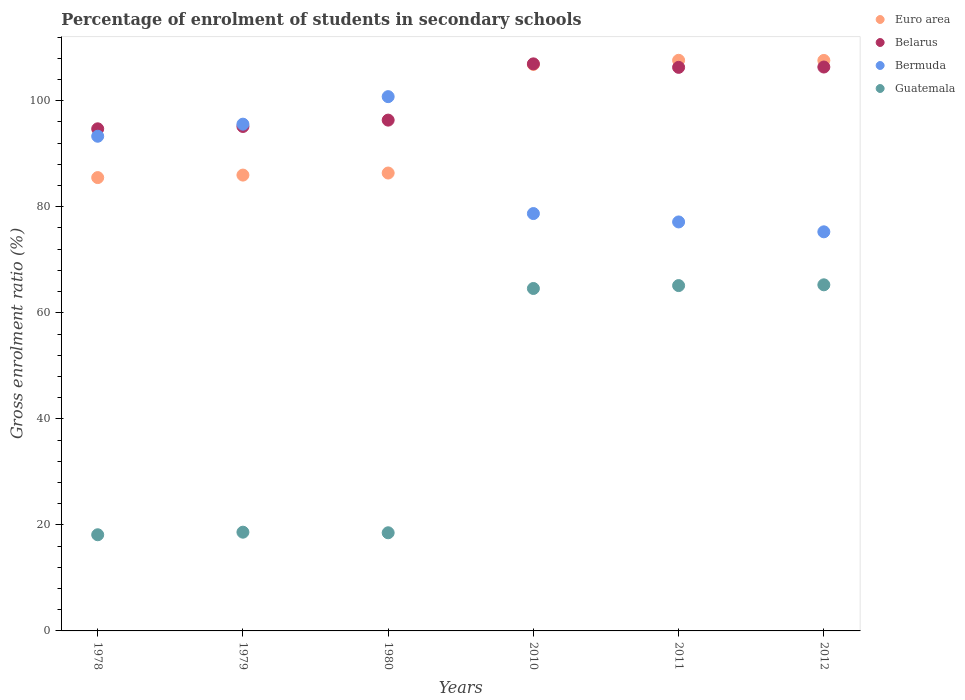What is the percentage of students enrolled in secondary schools in Euro area in 2011?
Offer a terse response. 107.63. Across all years, what is the maximum percentage of students enrolled in secondary schools in Bermuda?
Offer a very short reply. 100.78. Across all years, what is the minimum percentage of students enrolled in secondary schools in Guatemala?
Give a very brief answer. 18.14. In which year was the percentage of students enrolled in secondary schools in Euro area maximum?
Give a very brief answer. 2011. In which year was the percentage of students enrolled in secondary schools in Belarus minimum?
Make the answer very short. 1978. What is the total percentage of students enrolled in secondary schools in Euro area in the graph?
Your answer should be very brief. 579.94. What is the difference between the percentage of students enrolled in secondary schools in Belarus in 1978 and that in 2012?
Keep it short and to the point. -11.65. What is the difference between the percentage of students enrolled in secondary schools in Belarus in 2011 and the percentage of students enrolled in secondary schools in Bermuda in 1979?
Your response must be concise. 10.72. What is the average percentage of students enrolled in secondary schools in Euro area per year?
Ensure brevity in your answer.  96.66. In the year 2011, what is the difference between the percentage of students enrolled in secondary schools in Belarus and percentage of students enrolled in secondary schools in Guatemala?
Provide a short and direct response. 41.17. What is the ratio of the percentage of students enrolled in secondary schools in Belarus in 2010 to that in 2011?
Your response must be concise. 1.01. Is the percentage of students enrolled in secondary schools in Euro area in 2010 less than that in 2012?
Provide a succinct answer. Yes. Is the difference between the percentage of students enrolled in secondary schools in Belarus in 2010 and 2012 greater than the difference between the percentage of students enrolled in secondary schools in Guatemala in 2010 and 2012?
Offer a terse response. Yes. What is the difference between the highest and the second highest percentage of students enrolled in secondary schools in Guatemala?
Your answer should be very brief. 0.15. What is the difference between the highest and the lowest percentage of students enrolled in secondary schools in Bermuda?
Ensure brevity in your answer.  25.5. In how many years, is the percentage of students enrolled in secondary schools in Euro area greater than the average percentage of students enrolled in secondary schools in Euro area taken over all years?
Offer a terse response. 3. Is the sum of the percentage of students enrolled in secondary schools in Guatemala in 1979 and 2012 greater than the maximum percentage of students enrolled in secondary schools in Euro area across all years?
Give a very brief answer. No. Is it the case that in every year, the sum of the percentage of students enrolled in secondary schools in Euro area and percentage of students enrolled in secondary schools in Belarus  is greater than the sum of percentage of students enrolled in secondary schools in Guatemala and percentage of students enrolled in secondary schools in Bermuda?
Your answer should be very brief. Yes. Is it the case that in every year, the sum of the percentage of students enrolled in secondary schools in Euro area and percentage of students enrolled in secondary schools in Belarus  is greater than the percentage of students enrolled in secondary schools in Guatemala?
Your answer should be very brief. Yes. Is the percentage of students enrolled in secondary schools in Belarus strictly greater than the percentage of students enrolled in secondary schools in Guatemala over the years?
Make the answer very short. Yes. How many dotlines are there?
Ensure brevity in your answer.  4. How many years are there in the graph?
Your answer should be very brief. 6. What is the difference between two consecutive major ticks on the Y-axis?
Keep it short and to the point. 20. Are the values on the major ticks of Y-axis written in scientific E-notation?
Your answer should be compact. No. Does the graph contain any zero values?
Offer a very short reply. No. What is the title of the graph?
Your response must be concise. Percentage of enrolment of students in secondary schools. What is the label or title of the X-axis?
Your answer should be very brief. Years. What is the Gross enrolment ratio (%) of Euro area in 1978?
Offer a terse response. 85.51. What is the Gross enrolment ratio (%) of Belarus in 1978?
Your answer should be very brief. 94.71. What is the Gross enrolment ratio (%) of Bermuda in 1978?
Provide a succinct answer. 93.31. What is the Gross enrolment ratio (%) in Guatemala in 1978?
Provide a short and direct response. 18.14. What is the Gross enrolment ratio (%) of Euro area in 1979?
Your response must be concise. 85.98. What is the Gross enrolment ratio (%) of Belarus in 1979?
Make the answer very short. 95.15. What is the Gross enrolment ratio (%) of Bermuda in 1979?
Offer a terse response. 95.59. What is the Gross enrolment ratio (%) in Guatemala in 1979?
Make the answer very short. 18.62. What is the Gross enrolment ratio (%) of Euro area in 1980?
Give a very brief answer. 86.37. What is the Gross enrolment ratio (%) in Belarus in 1980?
Provide a succinct answer. 96.35. What is the Gross enrolment ratio (%) of Bermuda in 1980?
Offer a very short reply. 100.78. What is the Gross enrolment ratio (%) in Guatemala in 1980?
Make the answer very short. 18.51. What is the Gross enrolment ratio (%) of Euro area in 2010?
Offer a terse response. 106.85. What is the Gross enrolment ratio (%) of Belarus in 2010?
Give a very brief answer. 106.96. What is the Gross enrolment ratio (%) of Bermuda in 2010?
Ensure brevity in your answer.  78.72. What is the Gross enrolment ratio (%) of Guatemala in 2010?
Offer a very short reply. 64.59. What is the Gross enrolment ratio (%) in Euro area in 2011?
Give a very brief answer. 107.63. What is the Gross enrolment ratio (%) in Belarus in 2011?
Keep it short and to the point. 106.3. What is the Gross enrolment ratio (%) of Bermuda in 2011?
Provide a short and direct response. 77.14. What is the Gross enrolment ratio (%) in Guatemala in 2011?
Your answer should be very brief. 65.14. What is the Gross enrolment ratio (%) of Euro area in 2012?
Offer a terse response. 107.6. What is the Gross enrolment ratio (%) of Belarus in 2012?
Make the answer very short. 106.36. What is the Gross enrolment ratio (%) in Bermuda in 2012?
Offer a terse response. 75.28. What is the Gross enrolment ratio (%) in Guatemala in 2012?
Give a very brief answer. 65.28. Across all years, what is the maximum Gross enrolment ratio (%) of Euro area?
Your answer should be compact. 107.63. Across all years, what is the maximum Gross enrolment ratio (%) of Belarus?
Ensure brevity in your answer.  106.96. Across all years, what is the maximum Gross enrolment ratio (%) of Bermuda?
Keep it short and to the point. 100.78. Across all years, what is the maximum Gross enrolment ratio (%) in Guatemala?
Your response must be concise. 65.28. Across all years, what is the minimum Gross enrolment ratio (%) in Euro area?
Keep it short and to the point. 85.51. Across all years, what is the minimum Gross enrolment ratio (%) of Belarus?
Give a very brief answer. 94.71. Across all years, what is the minimum Gross enrolment ratio (%) of Bermuda?
Your answer should be compact. 75.28. Across all years, what is the minimum Gross enrolment ratio (%) in Guatemala?
Keep it short and to the point. 18.14. What is the total Gross enrolment ratio (%) in Euro area in the graph?
Offer a very short reply. 579.94. What is the total Gross enrolment ratio (%) of Belarus in the graph?
Provide a succinct answer. 605.83. What is the total Gross enrolment ratio (%) of Bermuda in the graph?
Your answer should be very brief. 520.82. What is the total Gross enrolment ratio (%) in Guatemala in the graph?
Your response must be concise. 250.29. What is the difference between the Gross enrolment ratio (%) of Euro area in 1978 and that in 1979?
Ensure brevity in your answer.  -0.47. What is the difference between the Gross enrolment ratio (%) of Belarus in 1978 and that in 1979?
Offer a very short reply. -0.44. What is the difference between the Gross enrolment ratio (%) of Bermuda in 1978 and that in 1979?
Your answer should be compact. -2.28. What is the difference between the Gross enrolment ratio (%) in Guatemala in 1978 and that in 1979?
Your response must be concise. -0.48. What is the difference between the Gross enrolment ratio (%) in Euro area in 1978 and that in 1980?
Offer a terse response. -0.86. What is the difference between the Gross enrolment ratio (%) in Belarus in 1978 and that in 1980?
Your answer should be very brief. -1.64. What is the difference between the Gross enrolment ratio (%) of Bermuda in 1978 and that in 1980?
Your answer should be compact. -7.47. What is the difference between the Gross enrolment ratio (%) in Guatemala in 1978 and that in 1980?
Provide a short and direct response. -0.37. What is the difference between the Gross enrolment ratio (%) of Euro area in 1978 and that in 2010?
Your response must be concise. -21.34. What is the difference between the Gross enrolment ratio (%) of Belarus in 1978 and that in 2010?
Provide a succinct answer. -12.25. What is the difference between the Gross enrolment ratio (%) in Bermuda in 1978 and that in 2010?
Offer a very short reply. 14.58. What is the difference between the Gross enrolment ratio (%) in Guatemala in 1978 and that in 2010?
Provide a succinct answer. -46.45. What is the difference between the Gross enrolment ratio (%) in Euro area in 1978 and that in 2011?
Your answer should be very brief. -22.12. What is the difference between the Gross enrolment ratio (%) of Belarus in 1978 and that in 2011?
Provide a short and direct response. -11.59. What is the difference between the Gross enrolment ratio (%) of Bermuda in 1978 and that in 2011?
Your answer should be very brief. 16.16. What is the difference between the Gross enrolment ratio (%) of Guatemala in 1978 and that in 2011?
Provide a short and direct response. -47. What is the difference between the Gross enrolment ratio (%) of Euro area in 1978 and that in 2012?
Provide a short and direct response. -22.1. What is the difference between the Gross enrolment ratio (%) in Belarus in 1978 and that in 2012?
Provide a succinct answer. -11.65. What is the difference between the Gross enrolment ratio (%) in Bermuda in 1978 and that in 2012?
Provide a short and direct response. 18.03. What is the difference between the Gross enrolment ratio (%) of Guatemala in 1978 and that in 2012?
Provide a succinct answer. -47.14. What is the difference between the Gross enrolment ratio (%) of Euro area in 1979 and that in 1980?
Ensure brevity in your answer.  -0.39. What is the difference between the Gross enrolment ratio (%) of Belarus in 1979 and that in 1980?
Give a very brief answer. -1.2. What is the difference between the Gross enrolment ratio (%) in Bermuda in 1979 and that in 1980?
Give a very brief answer. -5.19. What is the difference between the Gross enrolment ratio (%) of Guatemala in 1979 and that in 1980?
Give a very brief answer. 0.11. What is the difference between the Gross enrolment ratio (%) of Euro area in 1979 and that in 2010?
Your answer should be very brief. -20.87. What is the difference between the Gross enrolment ratio (%) in Belarus in 1979 and that in 2010?
Provide a succinct answer. -11.81. What is the difference between the Gross enrolment ratio (%) of Bermuda in 1979 and that in 2010?
Your response must be concise. 16.86. What is the difference between the Gross enrolment ratio (%) of Guatemala in 1979 and that in 2010?
Your answer should be very brief. -45.97. What is the difference between the Gross enrolment ratio (%) in Euro area in 1979 and that in 2011?
Your answer should be very brief. -21.65. What is the difference between the Gross enrolment ratio (%) of Belarus in 1979 and that in 2011?
Make the answer very short. -11.15. What is the difference between the Gross enrolment ratio (%) of Bermuda in 1979 and that in 2011?
Offer a very short reply. 18.44. What is the difference between the Gross enrolment ratio (%) of Guatemala in 1979 and that in 2011?
Your answer should be very brief. -46.51. What is the difference between the Gross enrolment ratio (%) of Euro area in 1979 and that in 2012?
Your answer should be compact. -21.62. What is the difference between the Gross enrolment ratio (%) of Belarus in 1979 and that in 2012?
Provide a short and direct response. -11.21. What is the difference between the Gross enrolment ratio (%) in Bermuda in 1979 and that in 2012?
Your answer should be compact. 20.3. What is the difference between the Gross enrolment ratio (%) in Guatemala in 1979 and that in 2012?
Ensure brevity in your answer.  -46.66. What is the difference between the Gross enrolment ratio (%) in Euro area in 1980 and that in 2010?
Provide a short and direct response. -20.48. What is the difference between the Gross enrolment ratio (%) in Belarus in 1980 and that in 2010?
Ensure brevity in your answer.  -10.61. What is the difference between the Gross enrolment ratio (%) in Bermuda in 1980 and that in 2010?
Ensure brevity in your answer.  22.05. What is the difference between the Gross enrolment ratio (%) of Guatemala in 1980 and that in 2010?
Your answer should be very brief. -46.08. What is the difference between the Gross enrolment ratio (%) of Euro area in 1980 and that in 2011?
Your answer should be compact. -21.26. What is the difference between the Gross enrolment ratio (%) in Belarus in 1980 and that in 2011?
Your response must be concise. -9.95. What is the difference between the Gross enrolment ratio (%) of Bermuda in 1980 and that in 2011?
Offer a very short reply. 23.63. What is the difference between the Gross enrolment ratio (%) of Guatemala in 1980 and that in 2011?
Your answer should be compact. -46.63. What is the difference between the Gross enrolment ratio (%) of Euro area in 1980 and that in 2012?
Your response must be concise. -21.23. What is the difference between the Gross enrolment ratio (%) of Belarus in 1980 and that in 2012?
Make the answer very short. -10.01. What is the difference between the Gross enrolment ratio (%) of Bermuda in 1980 and that in 2012?
Ensure brevity in your answer.  25.5. What is the difference between the Gross enrolment ratio (%) of Guatemala in 1980 and that in 2012?
Offer a very short reply. -46.77. What is the difference between the Gross enrolment ratio (%) in Euro area in 2010 and that in 2011?
Provide a succinct answer. -0.78. What is the difference between the Gross enrolment ratio (%) of Belarus in 2010 and that in 2011?
Keep it short and to the point. 0.66. What is the difference between the Gross enrolment ratio (%) of Bermuda in 2010 and that in 2011?
Give a very brief answer. 1.58. What is the difference between the Gross enrolment ratio (%) of Guatemala in 2010 and that in 2011?
Keep it short and to the point. -0.55. What is the difference between the Gross enrolment ratio (%) in Euro area in 2010 and that in 2012?
Provide a succinct answer. -0.76. What is the difference between the Gross enrolment ratio (%) of Belarus in 2010 and that in 2012?
Your response must be concise. 0.6. What is the difference between the Gross enrolment ratio (%) in Bermuda in 2010 and that in 2012?
Your answer should be very brief. 3.44. What is the difference between the Gross enrolment ratio (%) of Guatemala in 2010 and that in 2012?
Keep it short and to the point. -0.69. What is the difference between the Gross enrolment ratio (%) in Euro area in 2011 and that in 2012?
Offer a very short reply. 0.03. What is the difference between the Gross enrolment ratio (%) of Belarus in 2011 and that in 2012?
Offer a terse response. -0.06. What is the difference between the Gross enrolment ratio (%) in Bermuda in 2011 and that in 2012?
Make the answer very short. 1.86. What is the difference between the Gross enrolment ratio (%) in Guatemala in 2011 and that in 2012?
Your answer should be very brief. -0.15. What is the difference between the Gross enrolment ratio (%) in Euro area in 1978 and the Gross enrolment ratio (%) in Belarus in 1979?
Give a very brief answer. -9.64. What is the difference between the Gross enrolment ratio (%) in Euro area in 1978 and the Gross enrolment ratio (%) in Bermuda in 1979?
Offer a very short reply. -10.08. What is the difference between the Gross enrolment ratio (%) in Euro area in 1978 and the Gross enrolment ratio (%) in Guatemala in 1979?
Ensure brevity in your answer.  66.88. What is the difference between the Gross enrolment ratio (%) of Belarus in 1978 and the Gross enrolment ratio (%) of Bermuda in 1979?
Provide a succinct answer. -0.88. What is the difference between the Gross enrolment ratio (%) of Belarus in 1978 and the Gross enrolment ratio (%) of Guatemala in 1979?
Offer a very short reply. 76.09. What is the difference between the Gross enrolment ratio (%) in Bermuda in 1978 and the Gross enrolment ratio (%) in Guatemala in 1979?
Make the answer very short. 74.68. What is the difference between the Gross enrolment ratio (%) of Euro area in 1978 and the Gross enrolment ratio (%) of Belarus in 1980?
Provide a short and direct response. -10.84. What is the difference between the Gross enrolment ratio (%) of Euro area in 1978 and the Gross enrolment ratio (%) of Bermuda in 1980?
Make the answer very short. -15.27. What is the difference between the Gross enrolment ratio (%) in Euro area in 1978 and the Gross enrolment ratio (%) in Guatemala in 1980?
Provide a succinct answer. 67. What is the difference between the Gross enrolment ratio (%) of Belarus in 1978 and the Gross enrolment ratio (%) of Bermuda in 1980?
Provide a succinct answer. -6.07. What is the difference between the Gross enrolment ratio (%) in Belarus in 1978 and the Gross enrolment ratio (%) in Guatemala in 1980?
Your answer should be compact. 76.2. What is the difference between the Gross enrolment ratio (%) of Bermuda in 1978 and the Gross enrolment ratio (%) of Guatemala in 1980?
Offer a very short reply. 74.79. What is the difference between the Gross enrolment ratio (%) in Euro area in 1978 and the Gross enrolment ratio (%) in Belarus in 2010?
Provide a short and direct response. -21.45. What is the difference between the Gross enrolment ratio (%) in Euro area in 1978 and the Gross enrolment ratio (%) in Bermuda in 2010?
Provide a succinct answer. 6.78. What is the difference between the Gross enrolment ratio (%) in Euro area in 1978 and the Gross enrolment ratio (%) in Guatemala in 2010?
Offer a very short reply. 20.92. What is the difference between the Gross enrolment ratio (%) in Belarus in 1978 and the Gross enrolment ratio (%) in Bermuda in 2010?
Give a very brief answer. 15.98. What is the difference between the Gross enrolment ratio (%) in Belarus in 1978 and the Gross enrolment ratio (%) in Guatemala in 2010?
Offer a terse response. 30.12. What is the difference between the Gross enrolment ratio (%) of Bermuda in 1978 and the Gross enrolment ratio (%) of Guatemala in 2010?
Provide a succinct answer. 28.71. What is the difference between the Gross enrolment ratio (%) in Euro area in 1978 and the Gross enrolment ratio (%) in Belarus in 2011?
Ensure brevity in your answer.  -20.79. What is the difference between the Gross enrolment ratio (%) of Euro area in 1978 and the Gross enrolment ratio (%) of Bermuda in 2011?
Make the answer very short. 8.37. What is the difference between the Gross enrolment ratio (%) in Euro area in 1978 and the Gross enrolment ratio (%) in Guatemala in 2011?
Offer a terse response. 20.37. What is the difference between the Gross enrolment ratio (%) of Belarus in 1978 and the Gross enrolment ratio (%) of Bermuda in 2011?
Keep it short and to the point. 17.57. What is the difference between the Gross enrolment ratio (%) of Belarus in 1978 and the Gross enrolment ratio (%) of Guatemala in 2011?
Your response must be concise. 29.57. What is the difference between the Gross enrolment ratio (%) of Bermuda in 1978 and the Gross enrolment ratio (%) of Guatemala in 2011?
Your response must be concise. 28.17. What is the difference between the Gross enrolment ratio (%) of Euro area in 1978 and the Gross enrolment ratio (%) of Belarus in 2012?
Offer a terse response. -20.86. What is the difference between the Gross enrolment ratio (%) in Euro area in 1978 and the Gross enrolment ratio (%) in Bermuda in 2012?
Your answer should be very brief. 10.23. What is the difference between the Gross enrolment ratio (%) in Euro area in 1978 and the Gross enrolment ratio (%) in Guatemala in 2012?
Keep it short and to the point. 20.22. What is the difference between the Gross enrolment ratio (%) of Belarus in 1978 and the Gross enrolment ratio (%) of Bermuda in 2012?
Offer a very short reply. 19.43. What is the difference between the Gross enrolment ratio (%) in Belarus in 1978 and the Gross enrolment ratio (%) in Guatemala in 2012?
Your answer should be compact. 29.43. What is the difference between the Gross enrolment ratio (%) in Bermuda in 1978 and the Gross enrolment ratio (%) in Guatemala in 2012?
Keep it short and to the point. 28.02. What is the difference between the Gross enrolment ratio (%) in Euro area in 1979 and the Gross enrolment ratio (%) in Belarus in 1980?
Provide a short and direct response. -10.37. What is the difference between the Gross enrolment ratio (%) of Euro area in 1979 and the Gross enrolment ratio (%) of Bermuda in 1980?
Provide a short and direct response. -14.79. What is the difference between the Gross enrolment ratio (%) of Euro area in 1979 and the Gross enrolment ratio (%) of Guatemala in 1980?
Offer a terse response. 67.47. What is the difference between the Gross enrolment ratio (%) in Belarus in 1979 and the Gross enrolment ratio (%) in Bermuda in 1980?
Offer a very short reply. -5.63. What is the difference between the Gross enrolment ratio (%) of Belarus in 1979 and the Gross enrolment ratio (%) of Guatemala in 1980?
Your response must be concise. 76.64. What is the difference between the Gross enrolment ratio (%) of Bermuda in 1979 and the Gross enrolment ratio (%) of Guatemala in 1980?
Make the answer very short. 77.07. What is the difference between the Gross enrolment ratio (%) in Euro area in 1979 and the Gross enrolment ratio (%) in Belarus in 2010?
Your response must be concise. -20.98. What is the difference between the Gross enrolment ratio (%) in Euro area in 1979 and the Gross enrolment ratio (%) in Bermuda in 2010?
Offer a terse response. 7.26. What is the difference between the Gross enrolment ratio (%) in Euro area in 1979 and the Gross enrolment ratio (%) in Guatemala in 2010?
Your response must be concise. 21.39. What is the difference between the Gross enrolment ratio (%) of Belarus in 1979 and the Gross enrolment ratio (%) of Bermuda in 2010?
Give a very brief answer. 16.43. What is the difference between the Gross enrolment ratio (%) of Belarus in 1979 and the Gross enrolment ratio (%) of Guatemala in 2010?
Keep it short and to the point. 30.56. What is the difference between the Gross enrolment ratio (%) in Bermuda in 1979 and the Gross enrolment ratio (%) in Guatemala in 2010?
Provide a short and direct response. 30.99. What is the difference between the Gross enrolment ratio (%) in Euro area in 1979 and the Gross enrolment ratio (%) in Belarus in 2011?
Make the answer very short. -20.32. What is the difference between the Gross enrolment ratio (%) of Euro area in 1979 and the Gross enrolment ratio (%) of Bermuda in 2011?
Your answer should be compact. 8.84. What is the difference between the Gross enrolment ratio (%) of Euro area in 1979 and the Gross enrolment ratio (%) of Guatemala in 2011?
Provide a short and direct response. 20.84. What is the difference between the Gross enrolment ratio (%) in Belarus in 1979 and the Gross enrolment ratio (%) in Bermuda in 2011?
Your answer should be very brief. 18.01. What is the difference between the Gross enrolment ratio (%) in Belarus in 1979 and the Gross enrolment ratio (%) in Guatemala in 2011?
Ensure brevity in your answer.  30.01. What is the difference between the Gross enrolment ratio (%) of Bermuda in 1979 and the Gross enrolment ratio (%) of Guatemala in 2011?
Your answer should be very brief. 30.45. What is the difference between the Gross enrolment ratio (%) in Euro area in 1979 and the Gross enrolment ratio (%) in Belarus in 2012?
Ensure brevity in your answer.  -20.38. What is the difference between the Gross enrolment ratio (%) of Euro area in 1979 and the Gross enrolment ratio (%) of Bermuda in 2012?
Give a very brief answer. 10.7. What is the difference between the Gross enrolment ratio (%) in Euro area in 1979 and the Gross enrolment ratio (%) in Guatemala in 2012?
Make the answer very short. 20.7. What is the difference between the Gross enrolment ratio (%) in Belarus in 1979 and the Gross enrolment ratio (%) in Bermuda in 2012?
Your answer should be very brief. 19.87. What is the difference between the Gross enrolment ratio (%) in Belarus in 1979 and the Gross enrolment ratio (%) in Guatemala in 2012?
Offer a very short reply. 29.87. What is the difference between the Gross enrolment ratio (%) in Bermuda in 1979 and the Gross enrolment ratio (%) in Guatemala in 2012?
Provide a short and direct response. 30.3. What is the difference between the Gross enrolment ratio (%) of Euro area in 1980 and the Gross enrolment ratio (%) of Belarus in 2010?
Your answer should be very brief. -20.59. What is the difference between the Gross enrolment ratio (%) of Euro area in 1980 and the Gross enrolment ratio (%) of Bermuda in 2010?
Give a very brief answer. 7.65. What is the difference between the Gross enrolment ratio (%) in Euro area in 1980 and the Gross enrolment ratio (%) in Guatemala in 2010?
Your answer should be compact. 21.78. What is the difference between the Gross enrolment ratio (%) in Belarus in 1980 and the Gross enrolment ratio (%) in Bermuda in 2010?
Provide a succinct answer. 17.62. What is the difference between the Gross enrolment ratio (%) in Belarus in 1980 and the Gross enrolment ratio (%) in Guatemala in 2010?
Provide a short and direct response. 31.76. What is the difference between the Gross enrolment ratio (%) of Bermuda in 1980 and the Gross enrolment ratio (%) of Guatemala in 2010?
Your answer should be very brief. 36.18. What is the difference between the Gross enrolment ratio (%) of Euro area in 1980 and the Gross enrolment ratio (%) of Belarus in 2011?
Provide a succinct answer. -19.93. What is the difference between the Gross enrolment ratio (%) of Euro area in 1980 and the Gross enrolment ratio (%) of Bermuda in 2011?
Your answer should be compact. 9.23. What is the difference between the Gross enrolment ratio (%) of Euro area in 1980 and the Gross enrolment ratio (%) of Guatemala in 2011?
Offer a terse response. 21.23. What is the difference between the Gross enrolment ratio (%) of Belarus in 1980 and the Gross enrolment ratio (%) of Bermuda in 2011?
Provide a succinct answer. 19.21. What is the difference between the Gross enrolment ratio (%) of Belarus in 1980 and the Gross enrolment ratio (%) of Guatemala in 2011?
Provide a short and direct response. 31.21. What is the difference between the Gross enrolment ratio (%) of Bermuda in 1980 and the Gross enrolment ratio (%) of Guatemala in 2011?
Keep it short and to the point. 35.64. What is the difference between the Gross enrolment ratio (%) of Euro area in 1980 and the Gross enrolment ratio (%) of Belarus in 2012?
Provide a short and direct response. -19.99. What is the difference between the Gross enrolment ratio (%) in Euro area in 1980 and the Gross enrolment ratio (%) in Bermuda in 2012?
Give a very brief answer. 11.09. What is the difference between the Gross enrolment ratio (%) in Euro area in 1980 and the Gross enrolment ratio (%) in Guatemala in 2012?
Keep it short and to the point. 21.09. What is the difference between the Gross enrolment ratio (%) of Belarus in 1980 and the Gross enrolment ratio (%) of Bermuda in 2012?
Ensure brevity in your answer.  21.07. What is the difference between the Gross enrolment ratio (%) in Belarus in 1980 and the Gross enrolment ratio (%) in Guatemala in 2012?
Offer a terse response. 31.07. What is the difference between the Gross enrolment ratio (%) in Bermuda in 1980 and the Gross enrolment ratio (%) in Guatemala in 2012?
Give a very brief answer. 35.49. What is the difference between the Gross enrolment ratio (%) in Euro area in 2010 and the Gross enrolment ratio (%) in Belarus in 2011?
Ensure brevity in your answer.  0.55. What is the difference between the Gross enrolment ratio (%) in Euro area in 2010 and the Gross enrolment ratio (%) in Bermuda in 2011?
Keep it short and to the point. 29.71. What is the difference between the Gross enrolment ratio (%) in Euro area in 2010 and the Gross enrolment ratio (%) in Guatemala in 2011?
Give a very brief answer. 41.71. What is the difference between the Gross enrolment ratio (%) of Belarus in 2010 and the Gross enrolment ratio (%) of Bermuda in 2011?
Provide a short and direct response. 29.82. What is the difference between the Gross enrolment ratio (%) in Belarus in 2010 and the Gross enrolment ratio (%) in Guatemala in 2011?
Give a very brief answer. 41.82. What is the difference between the Gross enrolment ratio (%) of Bermuda in 2010 and the Gross enrolment ratio (%) of Guatemala in 2011?
Provide a succinct answer. 13.59. What is the difference between the Gross enrolment ratio (%) in Euro area in 2010 and the Gross enrolment ratio (%) in Belarus in 2012?
Offer a very short reply. 0.48. What is the difference between the Gross enrolment ratio (%) of Euro area in 2010 and the Gross enrolment ratio (%) of Bermuda in 2012?
Provide a short and direct response. 31.57. What is the difference between the Gross enrolment ratio (%) of Euro area in 2010 and the Gross enrolment ratio (%) of Guatemala in 2012?
Provide a short and direct response. 41.56. What is the difference between the Gross enrolment ratio (%) in Belarus in 2010 and the Gross enrolment ratio (%) in Bermuda in 2012?
Your answer should be compact. 31.68. What is the difference between the Gross enrolment ratio (%) in Belarus in 2010 and the Gross enrolment ratio (%) in Guatemala in 2012?
Offer a very short reply. 41.68. What is the difference between the Gross enrolment ratio (%) in Bermuda in 2010 and the Gross enrolment ratio (%) in Guatemala in 2012?
Ensure brevity in your answer.  13.44. What is the difference between the Gross enrolment ratio (%) in Euro area in 2011 and the Gross enrolment ratio (%) in Belarus in 2012?
Your response must be concise. 1.27. What is the difference between the Gross enrolment ratio (%) in Euro area in 2011 and the Gross enrolment ratio (%) in Bermuda in 2012?
Ensure brevity in your answer.  32.35. What is the difference between the Gross enrolment ratio (%) in Euro area in 2011 and the Gross enrolment ratio (%) in Guatemala in 2012?
Make the answer very short. 42.35. What is the difference between the Gross enrolment ratio (%) in Belarus in 2011 and the Gross enrolment ratio (%) in Bermuda in 2012?
Offer a terse response. 31.02. What is the difference between the Gross enrolment ratio (%) in Belarus in 2011 and the Gross enrolment ratio (%) in Guatemala in 2012?
Provide a short and direct response. 41.02. What is the difference between the Gross enrolment ratio (%) in Bermuda in 2011 and the Gross enrolment ratio (%) in Guatemala in 2012?
Your answer should be compact. 11.86. What is the average Gross enrolment ratio (%) of Euro area per year?
Offer a very short reply. 96.66. What is the average Gross enrolment ratio (%) in Belarus per year?
Provide a succinct answer. 100.97. What is the average Gross enrolment ratio (%) in Bermuda per year?
Make the answer very short. 86.8. What is the average Gross enrolment ratio (%) in Guatemala per year?
Provide a short and direct response. 41.71. In the year 1978, what is the difference between the Gross enrolment ratio (%) in Euro area and Gross enrolment ratio (%) in Belarus?
Make the answer very short. -9.2. In the year 1978, what is the difference between the Gross enrolment ratio (%) in Euro area and Gross enrolment ratio (%) in Bermuda?
Make the answer very short. -7.8. In the year 1978, what is the difference between the Gross enrolment ratio (%) of Euro area and Gross enrolment ratio (%) of Guatemala?
Offer a very short reply. 67.37. In the year 1978, what is the difference between the Gross enrolment ratio (%) in Belarus and Gross enrolment ratio (%) in Bermuda?
Provide a succinct answer. 1.4. In the year 1978, what is the difference between the Gross enrolment ratio (%) in Belarus and Gross enrolment ratio (%) in Guatemala?
Your response must be concise. 76.57. In the year 1978, what is the difference between the Gross enrolment ratio (%) of Bermuda and Gross enrolment ratio (%) of Guatemala?
Provide a succinct answer. 75.17. In the year 1979, what is the difference between the Gross enrolment ratio (%) of Euro area and Gross enrolment ratio (%) of Belarus?
Provide a succinct answer. -9.17. In the year 1979, what is the difference between the Gross enrolment ratio (%) of Euro area and Gross enrolment ratio (%) of Bermuda?
Provide a succinct answer. -9.6. In the year 1979, what is the difference between the Gross enrolment ratio (%) of Euro area and Gross enrolment ratio (%) of Guatemala?
Offer a very short reply. 67.36. In the year 1979, what is the difference between the Gross enrolment ratio (%) in Belarus and Gross enrolment ratio (%) in Bermuda?
Provide a succinct answer. -0.44. In the year 1979, what is the difference between the Gross enrolment ratio (%) of Belarus and Gross enrolment ratio (%) of Guatemala?
Give a very brief answer. 76.53. In the year 1979, what is the difference between the Gross enrolment ratio (%) in Bermuda and Gross enrolment ratio (%) in Guatemala?
Your answer should be compact. 76.96. In the year 1980, what is the difference between the Gross enrolment ratio (%) of Euro area and Gross enrolment ratio (%) of Belarus?
Provide a short and direct response. -9.98. In the year 1980, what is the difference between the Gross enrolment ratio (%) of Euro area and Gross enrolment ratio (%) of Bermuda?
Offer a very short reply. -14.41. In the year 1980, what is the difference between the Gross enrolment ratio (%) of Euro area and Gross enrolment ratio (%) of Guatemala?
Provide a succinct answer. 67.86. In the year 1980, what is the difference between the Gross enrolment ratio (%) in Belarus and Gross enrolment ratio (%) in Bermuda?
Your answer should be very brief. -4.43. In the year 1980, what is the difference between the Gross enrolment ratio (%) of Belarus and Gross enrolment ratio (%) of Guatemala?
Provide a short and direct response. 77.84. In the year 1980, what is the difference between the Gross enrolment ratio (%) in Bermuda and Gross enrolment ratio (%) in Guatemala?
Your response must be concise. 82.26. In the year 2010, what is the difference between the Gross enrolment ratio (%) of Euro area and Gross enrolment ratio (%) of Belarus?
Your response must be concise. -0.11. In the year 2010, what is the difference between the Gross enrolment ratio (%) in Euro area and Gross enrolment ratio (%) in Bermuda?
Your answer should be compact. 28.12. In the year 2010, what is the difference between the Gross enrolment ratio (%) of Euro area and Gross enrolment ratio (%) of Guatemala?
Offer a terse response. 42.26. In the year 2010, what is the difference between the Gross enrolment ratio (%) in Belarus and Gross enrolment ratio (%) in Bermuda?
Your answer should be very brief. 28.24. In the year 2010, what is the difference between the Gross enrolment ratio (%) of Belarus and Gross enrolment ratio (%) of Guatemala?
Provide a short and direct response. 42.37. In the year 2010, what is the difference between the Gross enrolment ratio (%) of Bermuda and Gross enrolment ratio (%) of Guatemala?
Your answer should be very brief. 14.13. In the year 2011, what is the difference between the Gross enrolment ratio (%) of Euro area and Gross enrolment ratio (%) of Belarus?
Keep it short and to the point. 1.33. In the year 2011, what is the difference between the Gross enrolment ratio (%) in Euro area and Gross enrolment ratio (%) in Bermuda?
Offer a very short reply. 30.49. In the year 2011, what is the difference between the Gross enrolment ratio (%) of Euro area and Gross enrolment ratio (%) of Guatemala?
Offer a very short reply. 42.49. In the year 2011, what is the difference between the Gross enrolment ratio (%) in Belarus and Gross enrolment ratio (%) in Bermuda?
Your response must be concise. 29.16. In the year 2011, what is the difference between the Gross enrolment ratio (%) in Belarus and Gross enrolment ratio (%) in Guatemala?
Your answer should be very brief. 41.17. In the year 2011, what is the difference between the Gross enrolment ratio (%) in Bermuda and Gross enrolment ratio (%) in Guatemala?
Give a very brief answer. 12.01. In the year 2012, what is the difference between the Gross enrolment ratio (%) in Euro area and Gross enrolment ratio (%) in Belarus?
Ensure brevity in your answer.  1.24. In the year 2012, what is the difference between the Gross enrolment ratio (%) of Euro area and Gross enrolment ratio (%) of Bermuda?
Ensure brevity in your answer.  32.32. In the year 2012, what is the difference between the Gross enrolment ratio (%) of Euro area and Gross enrolment ratio (%) of Guatemala?
Make the answer very short. 42.32. In the year 2012, what is the difference between the Gross enrolment ratio (%) in Belarus and Gross enrolment ratio (%) in Bermuda?
Give a very brief answer. 31.08. In the year 2012, what is the difference between the Gross enrolment ratio (%) of Belarus and Gross enrolment ratio (%) of Guatemala?
Ensure brevity in your answer.  41.08. In the year 2012, what is the difference between the Gross enrolment ratio (%) of Bermuda and Gross enrolment ratio (%) of Guatemala?
Provide a succinct answer. 10. What is the ratio of the Gross enrolment ratio (%) of Bermuda in 1978 to that in 1979?
Offer a very short reply. 0.98. What is the ratio of the Gross enrolment ratio (%) of Euro area in 1978 to that in 1980?
Your response must be concise. 0.99. What is the ratio of the Gross enrolment ratio (%) of Bermuda in 1978 to that in 1980?
Your response must be concise. 0.93. What is the ratio of the Gross enrolment ratio (%) in Guatemala in 1978 to that in 1980?
Make the answer very short. 0.98. What is the ratio of the Gross enrolment ratio (%) of Euro area in 1978 to that in 2010?
Offer a very short reply. 0.8. What is the ratio of the Gross enrolment ratio (%) in Belarus in 1978 to that in 2010?
Your response must be concise. 0.89. What is the ratio of the Gross enrolment ratio (%) in Bermuda in 1978 to that in 2010?
Keep it short and to the point. 1.19. What is the ratio of the Gross enrolment ratio (%) in Guatemala in 1978 to that in 2010?
Offer a very short reply. 0.28. What is the ratio of the Gross enrolment ratio (%) in Euro area in 1978 to that in 2011?
Provide a short and direct response. 0.79. What is the ratio of the Gross enrolment ratio (%) of Belarus in 1978 to that in 2011?
Your answer should be very brief. 0.89. What is the ratio of the Gross enrolment ratio (%) in Bermuda in 1978 to that in 2011?
Offer a very short reply. 1.21. What is the ratio of the Gross enrolment ratio (%) of Guatemala in 1978 to that in 2011?
Keep it short and to the point. 0.28. What is the ratio of the Gross enrolment ratio (%) in Euro area in 1978 to that in 2012?
Make the answer very short. 0.79. What is the ratio of the Gross enrolment ratio (%) in Belarus in 1978 to that in 2012?
Offer a very short reply. 0.89. What is the ratio of the Gross enrolment ratio (%) in Bermuda in 1978 to that in 2012?
Your response must be concise. 1.24. What is the ratio of the Gross enrolment ratio (%) of Guatemala in 1978 to that in 2012?
Your answer should be very brief. 0.28. What is the ratio of the Gross enrolment ratio (%) of Belarus in 1979 to that in 1980?
Your answer should be compact. 0.99. What is the ratio of the Gross enrolment ratio (%) in Bermuda in 1979 to that in 1980?
Make the answer very short. 0.95. What is the ratio of the Gross enrolment ratio (%) in Euro area in 1979 to that in 2010?
Your response must be concise. 0.8. What is the ratio of the Gross enrolment ratio (%) in Belarus in 1979 to that in 2010?
Keep it short and to the point. 0.89. What is the ratio of the Gross enrolment ratio (%) of Bermuda in 1979 to that in 2010?
Offer a very short reply. 1.21. What is the ratio of the Gross enrolment ratio (%) in Guatemala in 1979 to that in 2010?
Your answer should be very brief. 0.29. What is the ratio of the Gross enrolment ratio (%) in Euro area in 1979 to that in 2011?
Provide a succinct answer. 0.8. What is the ratio of the Gross enrolment ratio (%) in Belarus in 1979 to that in 2011?
Give a very brief answer. 0.9. What is the ratio of the Gross enrolment ratio (%) in Bermuda in 1979 to that in 2011?
Provide a succinct answer. 1.24. What is the ratio of the Gross enrolment ratio (%) of Guatemala in 1979 to that in 2011?
Make the answer very short. 0.29. What is the ratio of the Gross enrolment ratio (%) in Euro area in 1979 to that in 2012?
Your answer should be very brief. 0.8. What is the ratio of the Gross enrolment ratio (%) in Belarus in 1979 to that in 2012?
Keep it short and to the point. 0.89. What is the ratio of the Gross enrolment ratio (%) in Bermuda in 1979 to that in 2012?
Your answer should be very brief. 1.27. What is the ratio of the Gross enrolment ratio (%) in Guatemala in 1979 to that in 2012?
Your response must be concise. 0.29. What is the ratio of the Gross enrolment ratio (%) of Euro area in 1980 to that in 2010?
Ensure brevity in your answer.  0.81. What is the ratio of the Gross enrolment ratio (%) of Belarus in 1980 to that in 2010?
Your answer should be compact. 0.9. What is the ratio of the Gross enrolment ratio (%) of Bermuda in 1980 to that in 2010?
Provide a short and direct response. 1.28. What is the ratio of the Gross enrolment ratio (%) in Guatemala in 1980 to that in 2010?
Give a very brief answer. 0.29. What is the ratio of the Gross enrolment ratio (%) in Euro area in 1980 to that in 2011?
Your answer should be very brief. 0.8. What is the ratio of the Gross enrolment ratio (%) of Belarus in 1980 to that in 2011?
Give a very brief answer. 0.91. What is the ratio of the Gross enrolment ratio (%) in Bermuda in 1980 to that in 2011?
Provide a short and direct response. 1.31. What is the ratio of the Gross enrolment ratio (%) in Guatemala in 1980 to that in 2011?
Provide a short and direct response. 0.28. What is the ratio of the Gross enrolment ratio (%) of Euro area in 1980 to that in 2012?
Ensure brevity in your answer.  0.8. What is the ratio of the Gross enrolment ratio (%) of Belarus in 1980 to that in 2012?
Make the answer very short. 0.91. What is the ratio of the Gross enrolment ratio (%) of Bermuda in 1980 to that in 2012?
Provide a short and direct response. 1.34. What is the ratio of the Gross enrolment ratio (%) of Guatemala in 1980 to that in 2012?
Offer a terse response. 0.28. What is the ratio of the Gross enrolment ratio (%) in Belarus in 2010 to that in 2011?
Your answer should be compact. 1.01. What is the ratio of the Gross enrolment ratio (%) in Bermuda in 2010 to that in 2011?
Keep it short and to the point. 1.02. What is the ratio of the Gross enrolment ratio (%) in Belarus in 2010 to that in 2012?
Make the answer very short. 1.01. What is the ratio of the Gross enrolment ratio (%) of Bermuda in 2010 to that in 2012?
Your response must be concise. 1.05. What is the ratio of the Gross enrolment ratio (%) of Guatemala in 2010 to that in 2012?
Provide a succinct answer. 0.99. What is the ratio of the Gross enrolment ratio (%) in Euro area in 2011 to that in 2012?
Provide a short and direct response. 1. What is the ratio of the Gross enrolment ratio (%) in Bermuda in 2011 to that in 2012?
Ensure brevity in your answer.  1.02. What is the ratio of the Gross enrolment ratio (%) in Guatemala in 2011 to that in 2012?
Provide a short and direct response. 1. What is the difference between the highest and the second highest Gross enrolment ratio (%) of Euro area?
Provide a succinct answer. 0.03. What is the difference between the highest and the second highest Gross enrolment ratio (%) of Belarus?
Your answer should be very brief. 0.6. What is the difference between the highest and the second highest Gross enrolment ratio (%) in Bermuda?
Provide a succinct answer. 5.19. What is the difference between the highest and the second highest Gross enrolment ratio (%) of Guatemala?
Make the answer very short. 0.15. What is the difference between the highest and the lowest Gross enrolment ratio (%) of Euro area?
Offer a very short reply. 22.12. What is the difference between the highest and the lowest Gross enrolment ratio (%) in Belarus?
Provide a short and direct response. 12.25. What is the difference between the highest and the lowest Gross enrolment ratio (%) in Bermuda?
Make the answer very short. 25.5. What is the difference between the highest and the lowest Gross enrolment ratio (%) in Guatemala?
Keep it short and to the point. 47.14. 